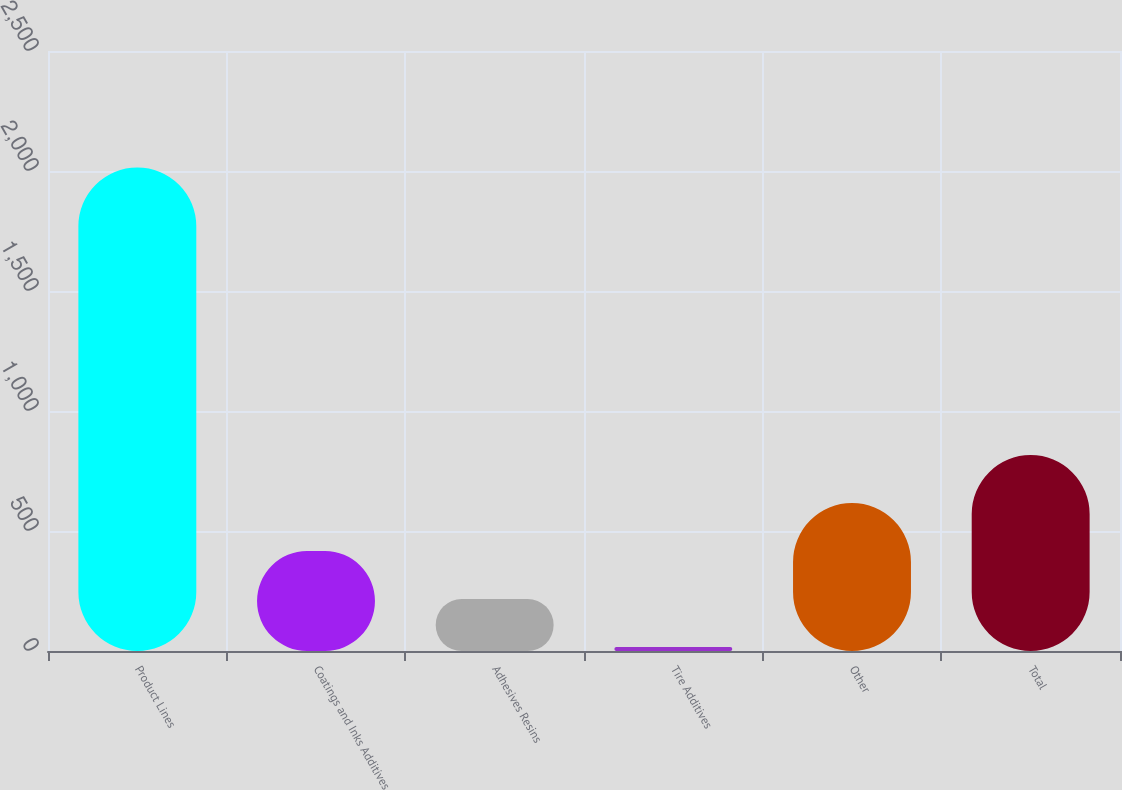Convert chart. <chart><loc_0><loc_0><loc_500><loc_500><bar_chart><fcel>Product Lines<fcel>Coatings and Inks Additives<fcel>Adhesives Resins<fcel>Tire Additives<fcel>Other<fcel>Total<nl><fcel>2015<fcel>416.6<fcel>216.8<fcel>17<fcel>616.4<fcel>816.2<nl></chart> 